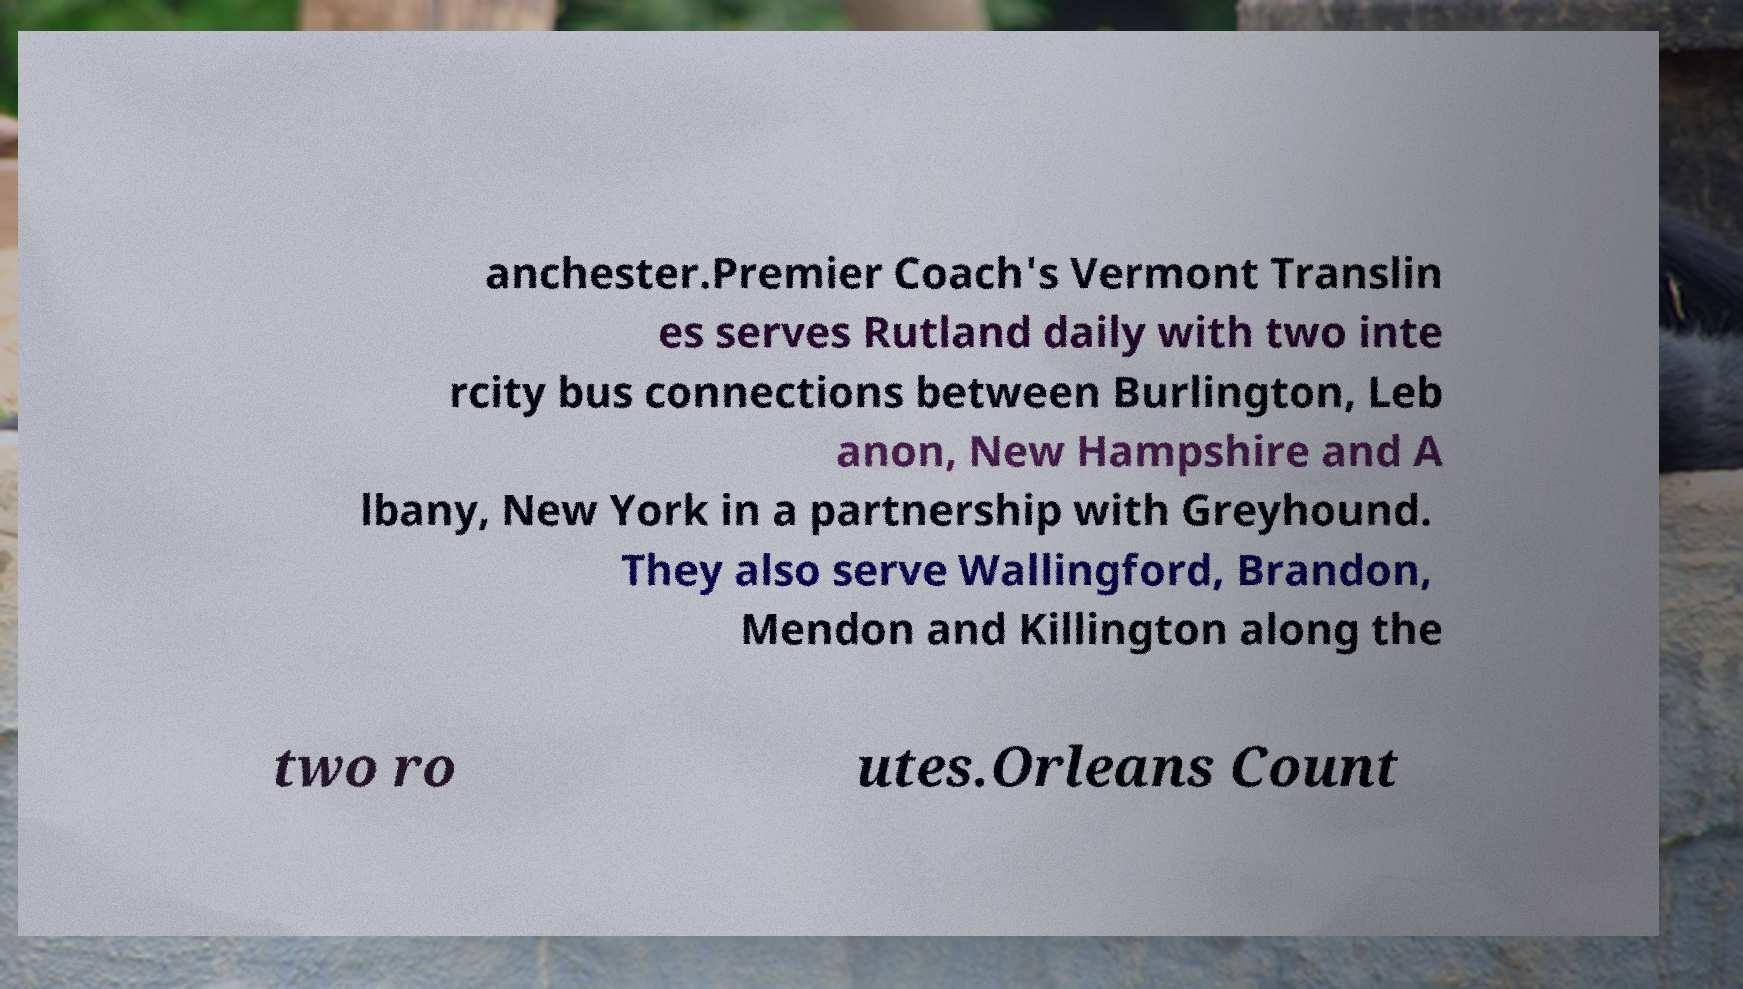Please identify and transcribe the text found in this image. anchester.Premier Coach's Vermont Translin es serves Rutland daily with two inte rcity bus connections between Burlington, Leb anon, New Hampshire and A lbany, New York in a partnership with Greyhound. They also serve Wallingford, Brandon, Mendon and Killington along the two ro utes.Orleans Count 